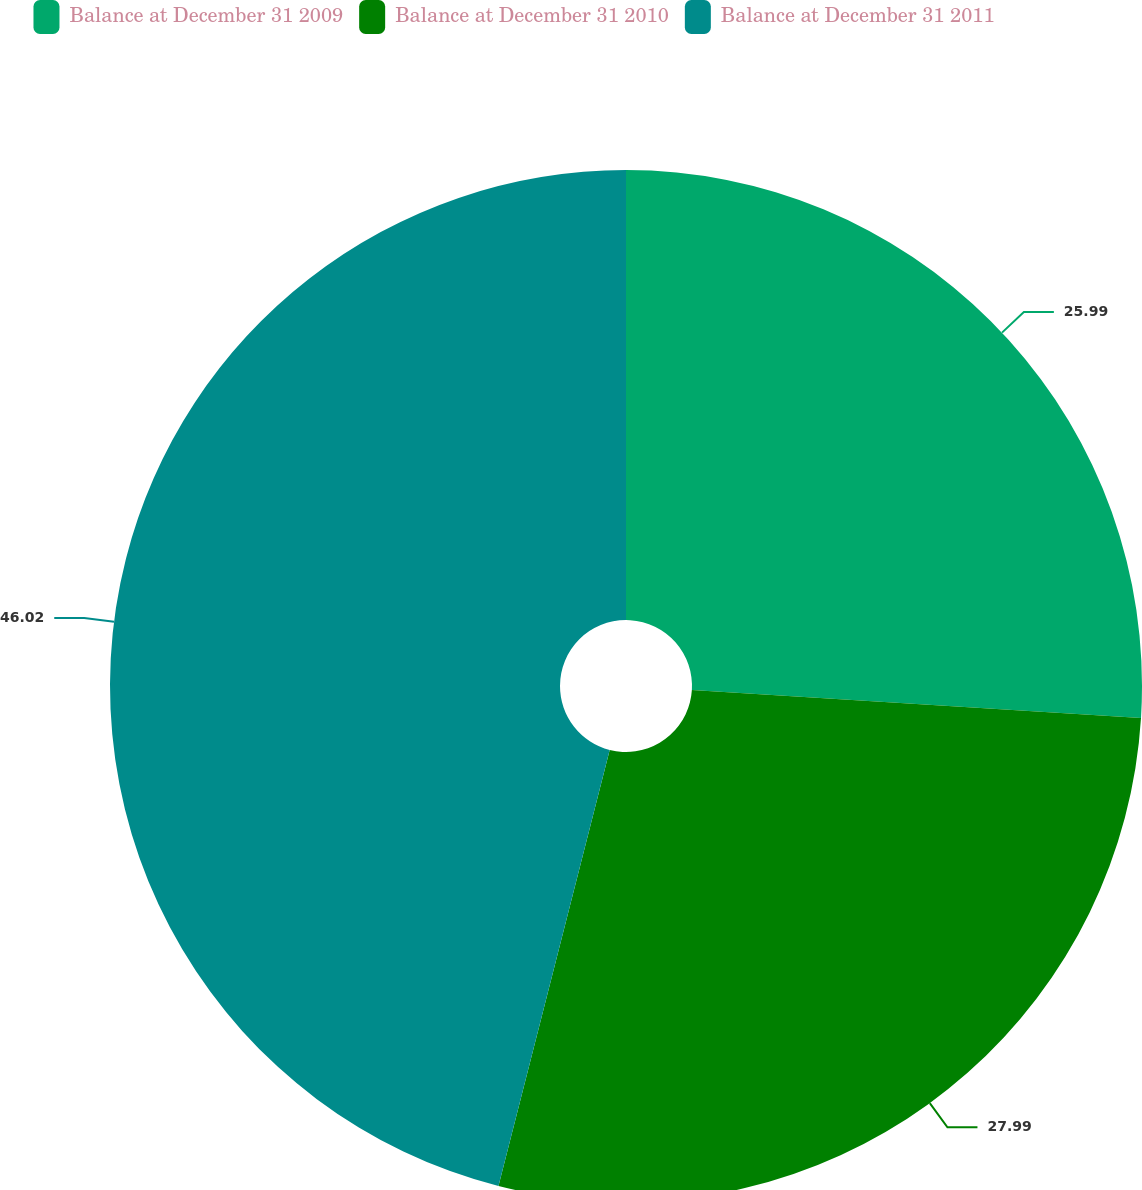Convert chart to OTSL. <chart><loc_0><loc_0><loc_500><loc_500><pie_chart><fcel>Balance at December 31 2009<fcel>Balance at December 31 2010<fcel>Balance at December 31 2011<nl><fcel>25.99%<fcel>27.99%<fcel>46.03%<nl></chart> 